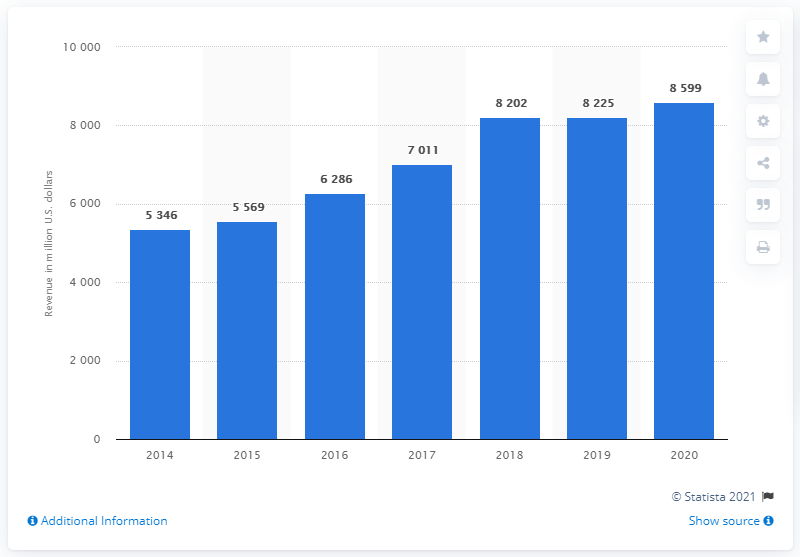Highlight a few significant elements in this photo. In 2020, Amphenol's net sales were $8,599. 